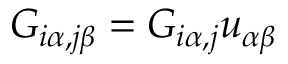Convert formula to latex. <formula><loc_0><loc_0><loc_500><loc_500>G _ { i \alpha , j \beta } = G _ { i \alpha , j } u _ { \alpha \beta }</formula> 